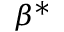<formula> <loc_0><loc_0><loc_500><loc_500>\beta ^ { * }</formula> 